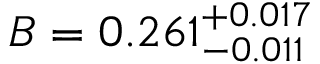Convert formula to latex. <formula><loc_0><loc_0><loc_500><loc_500>B = 0 . 2 6 1 _ { - 0 . 0 1 1 } ^ { + 0 . 0 1 7 }</formula> 